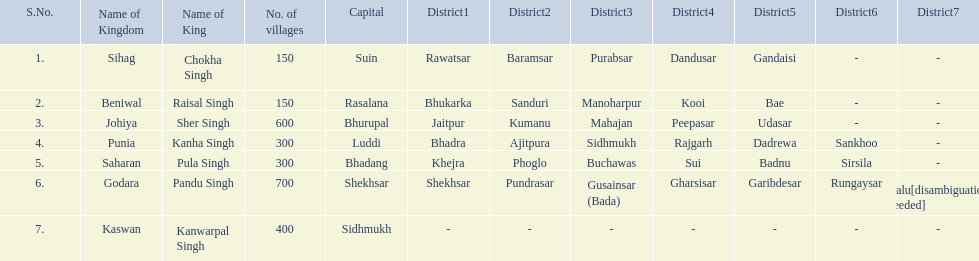What is the most amount of villages in a kingdom? 700. What is the second most amount of villages in a kingdom? 600. What kingdom has 600 villages? Johiya. 